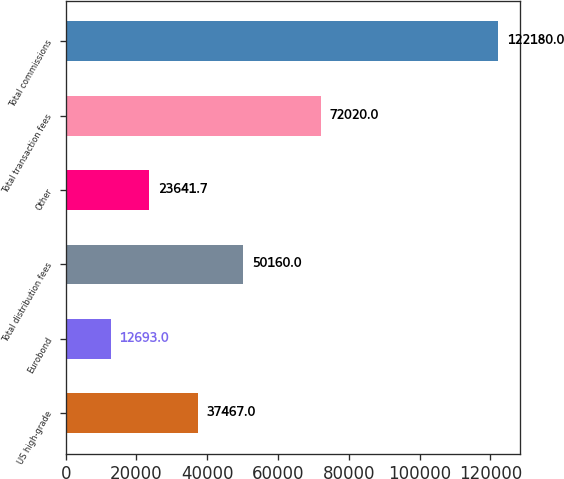Convert chart. <chart><loc_0><loc_0><loc_500><loc_500><bar_chart><fcel>US high-grade<fcel>Eurobond<fcel>Total distribution fees<fcel>Other<fcel>Total transaction fees<fcel>Total commissions<nl><fcel>37467<fcel>12693<fcel>50160<fcel>23641.7<fcel>72020<fcel>122180<nl></chart> 